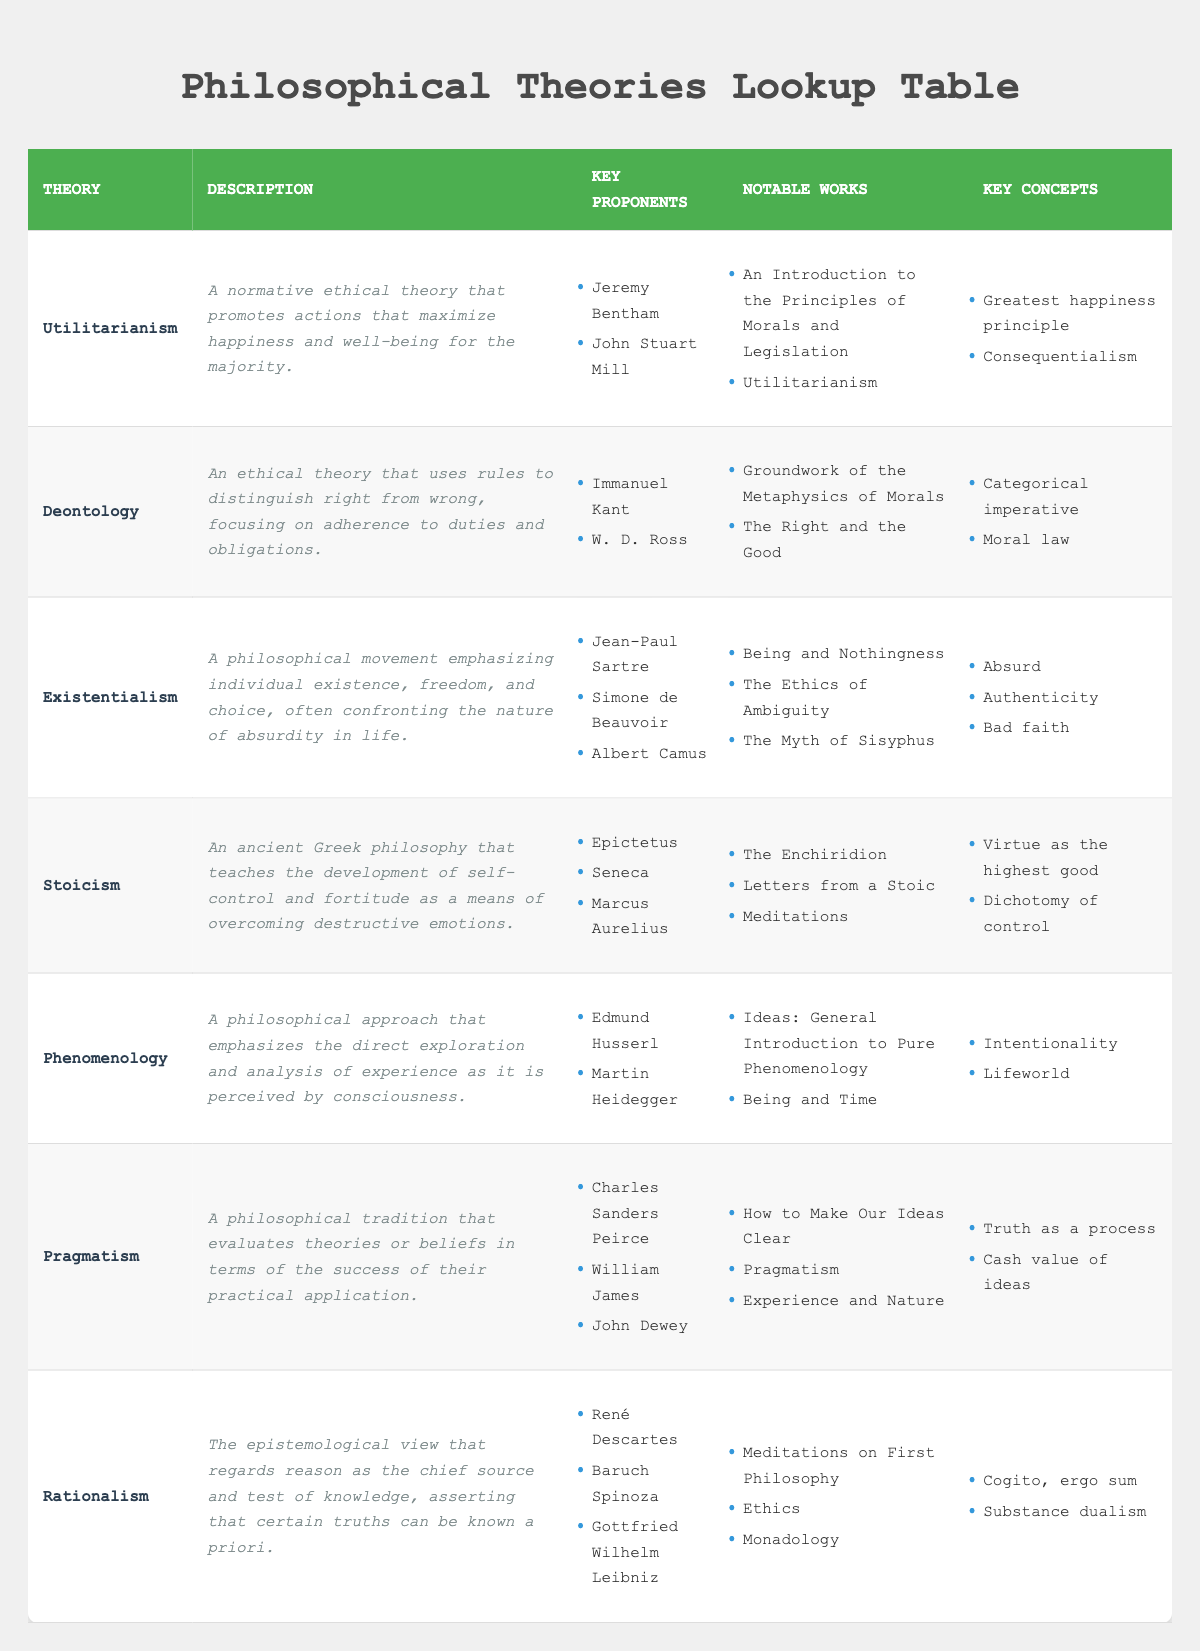What are the key proponents of Utilitarianism? The table lists two key proponents of Utilitarianism: Jeremy Bentham and John Stuart Mill, which can be found in the "Key Proponents" column for the row corresponding to Utilitarianism.
Answer: Jeremy Bentham, John Stuart Mill Which theory emphasizes individual existence and freedom? The description of Existentialism explains that it emphasizes individual existence, freedom, and choice. This can be found in the description column of the row for Existentialism.
Answer: Existentialism Does Stoicism focus on emotional control? The description of Stoicism indicates that it teaches the development of self-control to overcome destructive emotions, which confirms that it does focus on emotional control.
Answer: Yes How many notable works are associated with Pragmatism? The table shows three notable works in the "Notable Works" column under Pragmatism: "How to Make Our Ideas Clear," "Pragmatism," and "Experience and Nature." Therefore, there are three notable works associated with Pragmatism.
Answer: 3 Which philosophical theory has the concept of "Bad faith"? Within the "Key Concepts" column for the Existentialism row, "Bad faith" is specifically indicated, identifying that it is a concept associated with Existentialism.
Answer: Existentialism How many key proponents are associated with Rationalism? The table shows three key proponents listed under Rationalism: René Descartes, Baruch Spinoza, and Gottfried Wilhelm Leibniz. Therefore, there are three key proponents for this theory.
Answer: 3 Is "Being and Time" a notable work of Stoicism? The notable works listed for Stoicism do not include "Being and Time"; it is under the Existentialism theory instead. Hence, the statement is false.
Answer: No Which theory has the greatest number of key proponents? By counting the proponents from each theory, Existentialism has three proponents (Jean-Paul Sartre, Simone de Beauvoir, Albert Camus), which is more than the others listed, making it the theory with the greatest number of key proponents.
Answer: Existentialism 